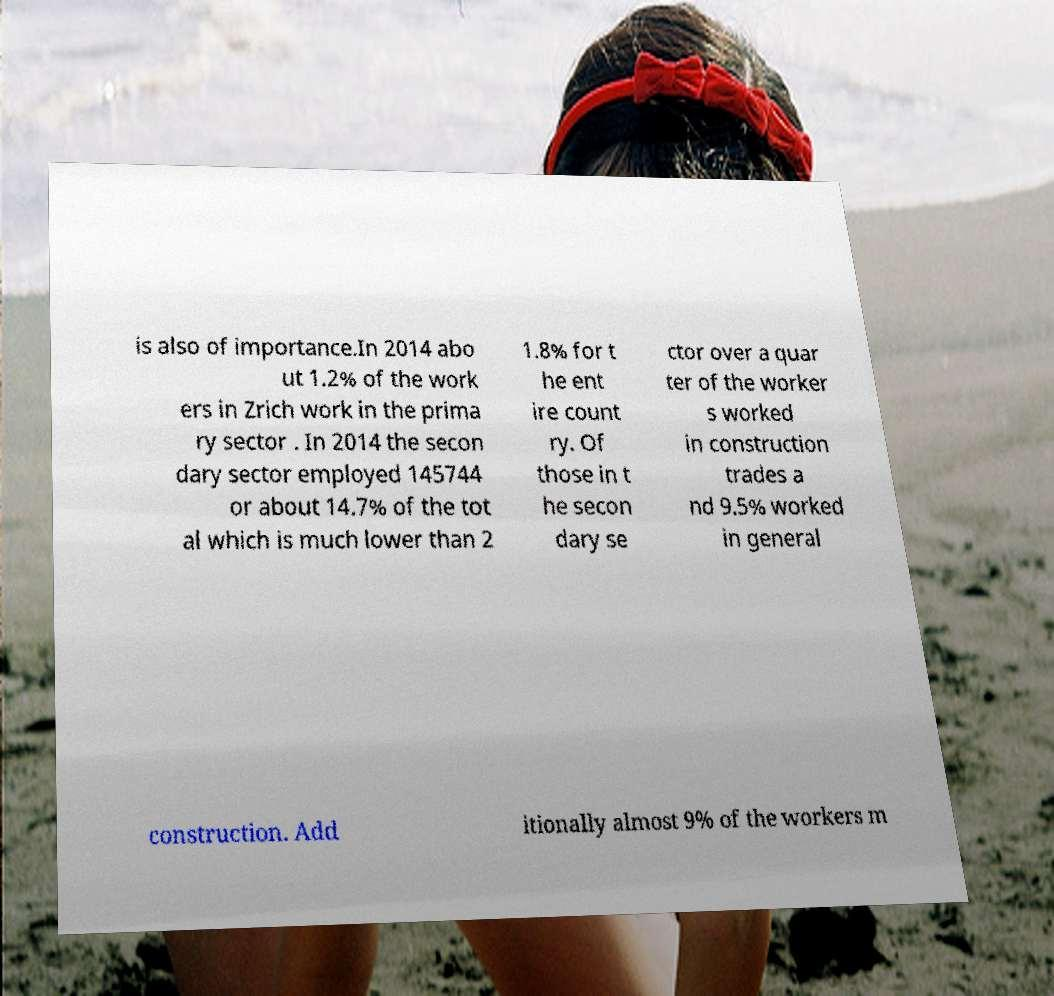Can you read and provide the text displayed in the image?This photo seems to have some interesting text. Can you extract and type it out for me? is also of importance.In 2014 abo ut 1.2% of the work ers in Zrich work in the prima ry sector . In 2014 the secon dary sector employed 145744 or about 14.7% of the tot al which is much lower than 2 1.8% for t he ent ire count ry. Of those in t he secon dary se ctor over a quar ter of the worker s worked in construction trades a nd 9.5% worked in general construction. Add itionally almost 9% of the workers m 